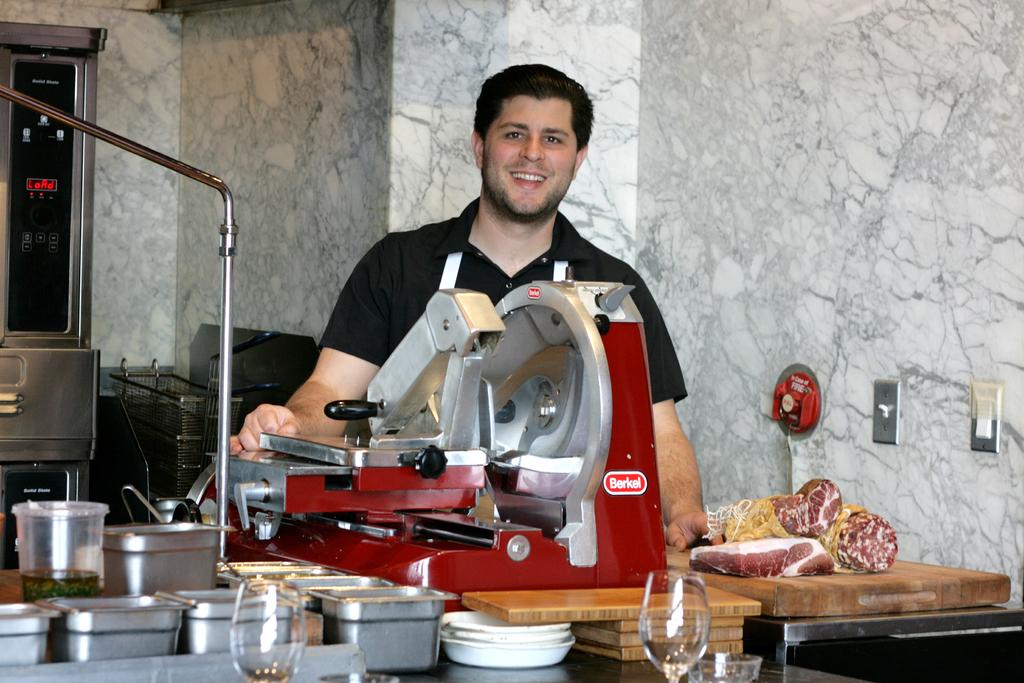What brand of equipment is the man using?
Your answer should be compact. Berkel. What is the brand of the slicer?
Keep it short and to the point. Berkel. 